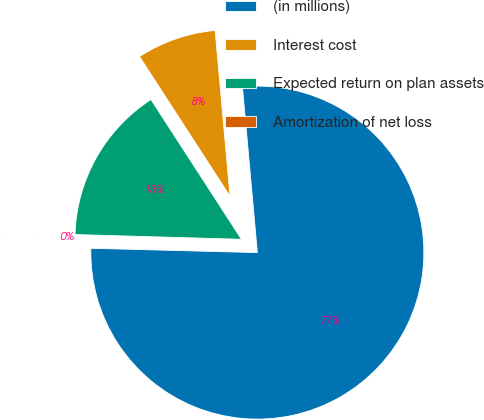<chart> <loc_0><loc_0><loc_500><loc_500><pie_chart><fcel>(in millions)<fcel>Interest cost<fcel>Expected return on plan assets<fcel>Amortization of net loss<nl><fcel>76.84%<fcel>7.72%<fcel>15.4%<fcel>0.04%<nl></chart> 